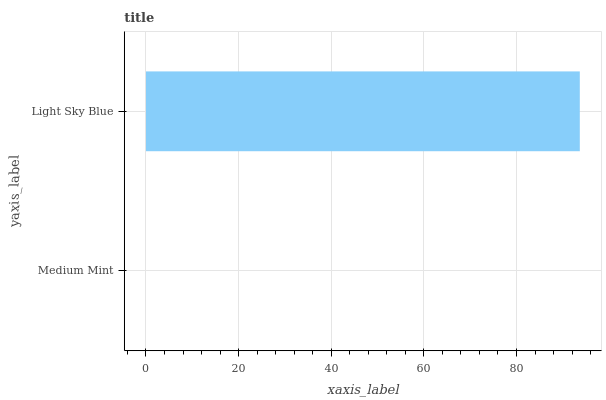Is Medium Mint the minimum?
Answer yes or no. Yes. Is Light Sky Blue the maximum?
Answer yes or no. Yes. Is Light Sky Blue the minimum?
Answer yes or no. No. Is Light Sky Blue greater than Medium Mint?
Answer yes or no. Yes. Is Medium Mint less than Light Sky Blue?
Answer yes or no. Yes. Is Medium Mint greater than Light Sky Blue?
Answer yes or no. No. Is Light Sky Blue less than Medium Mint?
Answer yes or no. No. Is Light Sky Blue the high median?
Answer yes or no. Yes. Is Medium Mint the low median?
Answer yes or no. Yes. Is Medium Mint the high median?
Answer yes or no. No. Is Light Sky Blue the low median?
Answer yes or no. No. 